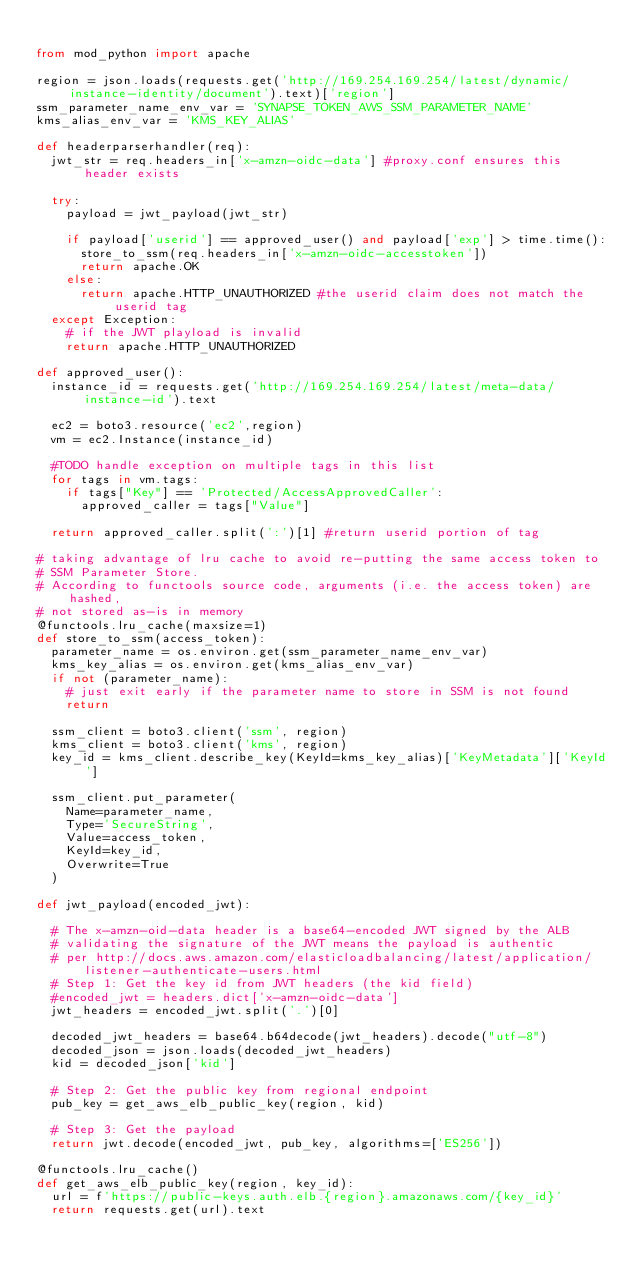Convert code to text. <code><loc_0><loc_0><loc_500><loc_500><_Python_>
from mod_python import apache

region = json.loads(requests.get('http://169.254.169.254/latest/dynamic/instance-identity/document').text)['region']
ssm_parameter_name_env_var = 'SYNAPSE_TOKEN_AWS_SSM_PARAMETER_NAME'
kms_alias_env_var = 'KMS_KEY_ALIAS'

def headerparserhandler(req):
  jwt_str = req.headers_in['x-amzn-oidc-data'] #proxy.conf ensures this header exists

  try:
    payload = jwt_payload(jwt_str)

    if payload['userid'] == approved_user() and payload['exp'] > time.time():
      store_to_ssm(req.headers_in['x-amzn-oidc-accesstoken'])
      return apache.OK
    else:
      return apache.HTTP_UNAUTHORIZED #the userid claim does not match the userid tag
  except Exception:
    # if the JWT playload is invalid
    return apache.HTTP_UNAUTHORIZED

def approved_user():
  instance_id = requests.get('http://169.254.169.254/latest/meta-data/instance-id').text

  ec2 = boto3.resource('ec2',region)
  vm = ec2.Instance(instance_id)

  #TODO handle exception on multiple tags in this list
  for tags in vm.tags:
    if tags["Key"] == 'Protected/AccessApprovedCaller':
      approved_caller = tags["Value"]

  return approved_caller.split(':')[1] #return userid portion of tag

# taking advantage of lru cache to avoid re-putting the same access token to
# SSM Parameter Store.
# According to functools source code, arguments (i.e. the access token) are hashed,
# not stored as-is in memory
@functools.lru_cache(maxsize=1)
def store_to_ssm(access_token):
  parameter_name = os.environ.get(ssm_parameter_name_env_var)
  kms_key_alias = os.environ.get(kms_alias_env_var)
  if not (parameter_name):
    # just exit early if the parameter name to store in SSM is not found
    return

  ssm_client = boto3.client('ssm', region)
  kms_client = boto3.client('kms', region)
  key_id = kms_client.describe_key(KeyId=kms_key_alias)['KeyMetadata']['KeyId']

  ssm_client.put_parameter(
    Name=parameter_name,
    Type='SecureString',
    Value=access_token,
    KeyId=key_id,
    Overwrite=True
  )

def jwt_payload(encoded_jwt):

  # The x-amzn-oid-data header is a base64-encoded JWT signed by the ALB
  # validating the signature of the JWT means the payload is authentic
  # per http://docs.aws.amazon.com/elasticloadbalancing/latest/application/listener-authenticate-users.html
  # Step 1: Get the key id from JWT headers (the kid field)
  #encoded_jwt = headers.dict['x-amzn-oidc-data']
  jwt_headers = encoded_jwt.split('.')[0]

  decoded_jwt_headers = base64.b64decode(jwt_headers).decode("utf-8")
  decoded_json = json.loads(decoded_jwt_headers)
  kid = decoded_json['kid']

  # Step 2: Get the public key from regional endpoint
  pub_key = get_aws_elb_public_key(region, kid)

  # Step 3: Get the payload
  return jwt.decode(encoded_jwt, pub_key, algorithms=['ES256'])

@functools.lru_cache()
def get_aws_elb_public_key(region, key_id):
  url = f'https://public-keys.auth.elb.{region}.amazonaws.com/{key_id}'
  return requests.get(url).text
</code> 